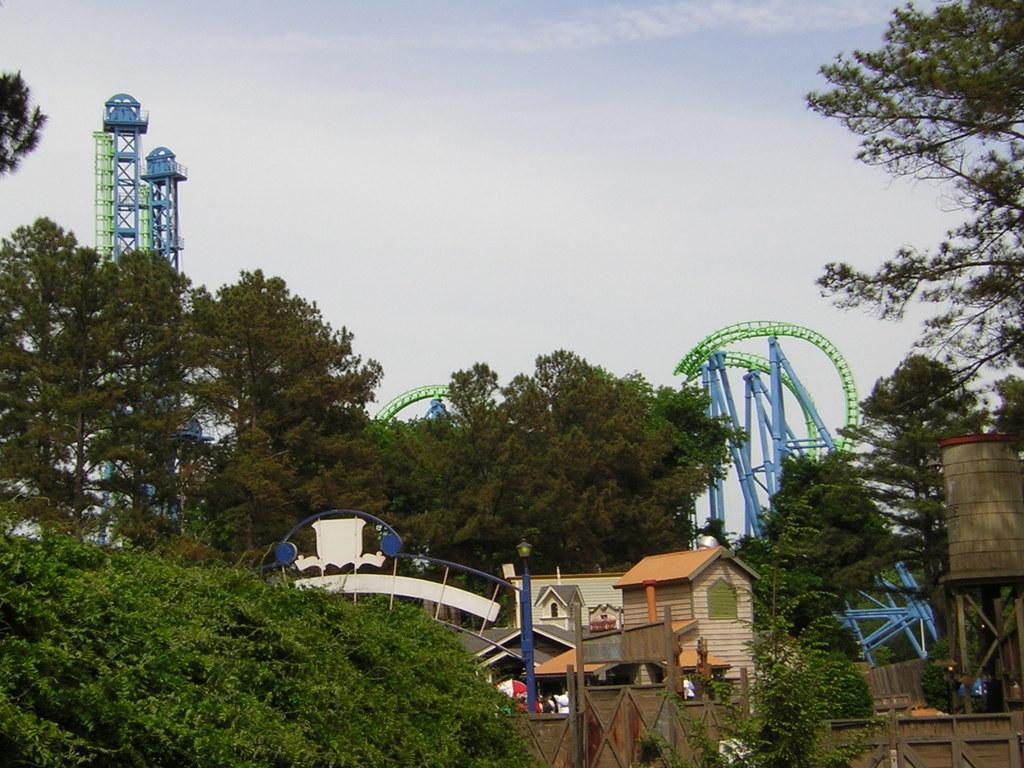How would you summarize this image in a sentence or two? In the foreground, I can see a fence, plants, trees, houses, board, poles and metal objects. In the background, I can see towers and the sky. This picture might be taken in a day. 